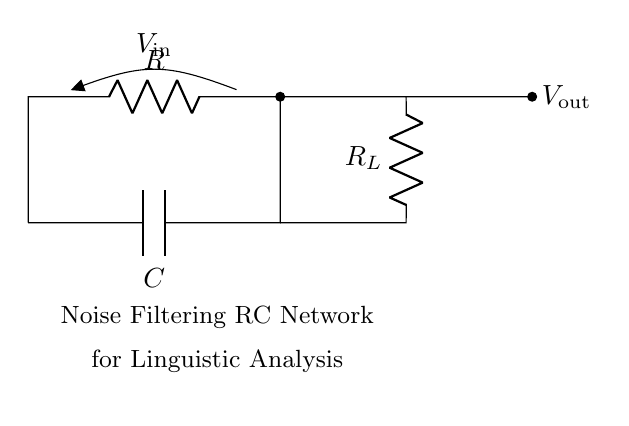What components are present in this circuit? The components seen in the circuit are a resistor denoted by R, a capacitor labeled C, and a load resistor represented as R_L.
Answer: Resistor, Capacitor, Load Resistor What is the function of the capacitor in this circuit? The capacitor filters high-frequency noise, allowing lower-frequency audio signals to pass through effectively, enhancing the signal quality for analysis.
Answer: Noise filtering What is the voltage at the input labeled V_in? The circuit does not specify a numerical value for V_in, but it is the voltage applied across the input resistor R.
Answer: Not specified What does V_out represent in this RC network? V_out indicates the output voltage, which is taken across the load resistor R_L after the filtering operation has taken place in the RC circuit.
Answer: Output voltage How does increasing resistance R affect the circuit? Increasing the resistance R will lower the cutoff frequency of the filter, allowing more low-frequency signals to pass while reducing the impact of high-frequency noise.
Answer: Lowers cutoff frequency What type of filtering does this RC network primarily perform? This RC network primarily performs low-pass filtering, which allows frequencies below the cutoff frequency to pass and attenuates frequencies above that threshold.
Answer: Low-pass filtering What role does the load resistor R_L serve in this circuit? The load resistor R_L is connected to measure the output voltage and ensures a proper load for the output signal, allowing the circuit to function correctly with the connected analysis equipment.
Answer: Measures output voltage 